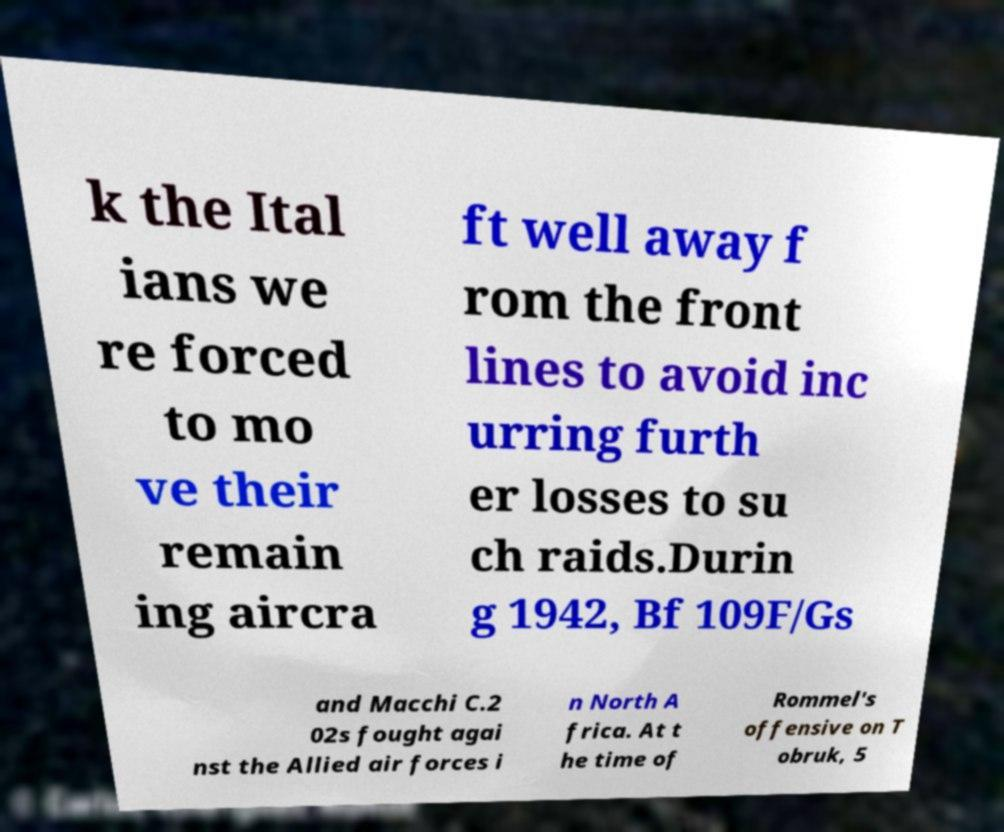Can you accurately transcribe the text from the provided image for me? k the Ital ians we re forced to mo ve their remain ing aircra ft well away f rom the front lines to avoid inc urring furth er losses to su ch raids.Durin g 1942, Bf 109F/Gs and Macchi C.2 02s fought agai nst the Allied air forces i n North A frica. At t he time of Rommel's offensive on T obruk, 5 